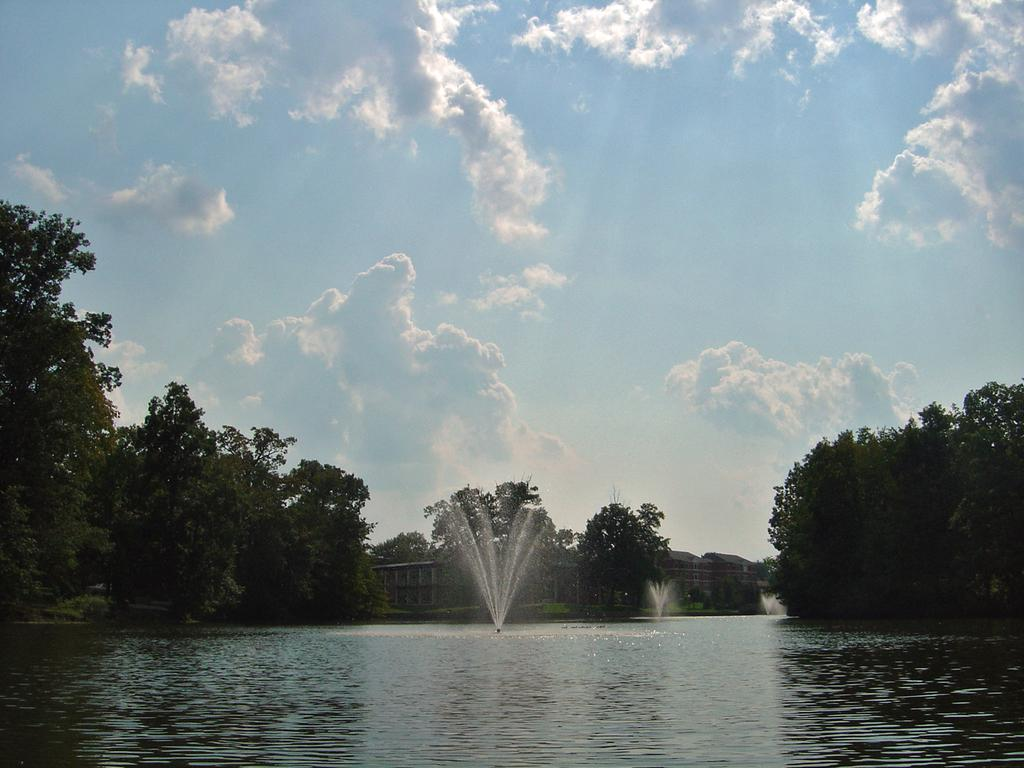What is the main feature in the center of the image? There is water in the center of the image. What structures are present in the image? There are fountains in the image. What can be seen in the background of the image? There are trees, buildings, and the sky visible in the background of the image. What type of zinc is being used to power the fountains in the image? There is no mention of zinc or any power source for the fountains in the image. What plot of land is the water located on in the image? The image does not provide information about the specific plot of land where the water is located. 